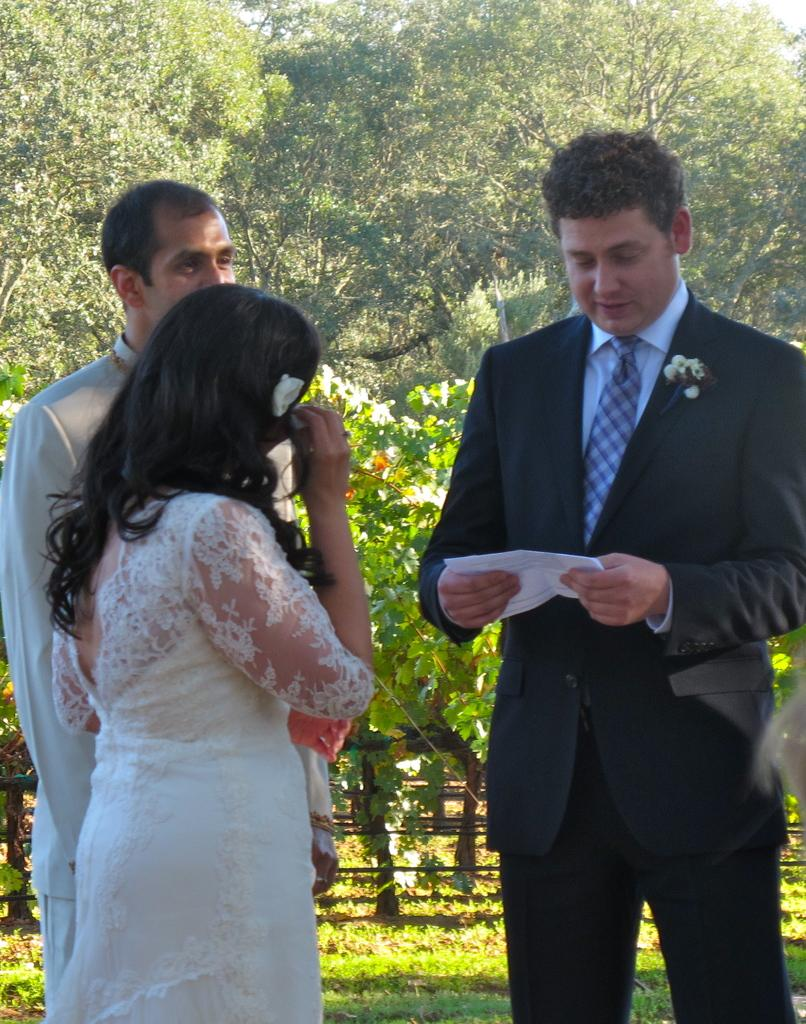How many people are present in the image? There are three persons standing in the image. What is one of the persons holding? One of the persons is holding a white-colored paper. What can be seen in the background of the image? There is grass, flowers, and multiple trees visible in the background of the image. What type of bun is being used as a prop in the image? There is no bun present in the image. Can you describe the apparatus that the persons are using to communicate with each other? There is no apparatus visible in the image; the persons are simply standing together. 